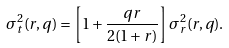Convert formula to latex. <formula><loc_0><loc_0><loc_500><loc_500>\sigma _ { t } ^ { 2 } ( r , q ) = \left [ 1 + \frac { q r } { 2 ( 1 + r ) } \right ] \sigma _ { r } ^ { 2 } ( r , q ) .</formula> 